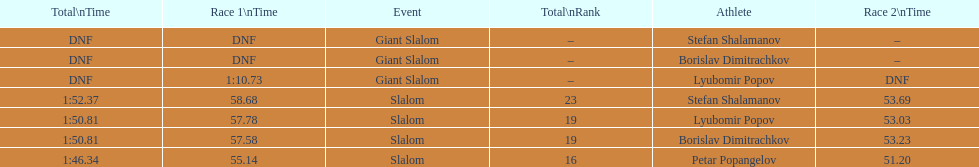What is the difference in time for petar popangelov in race 1and 2 3.94. 